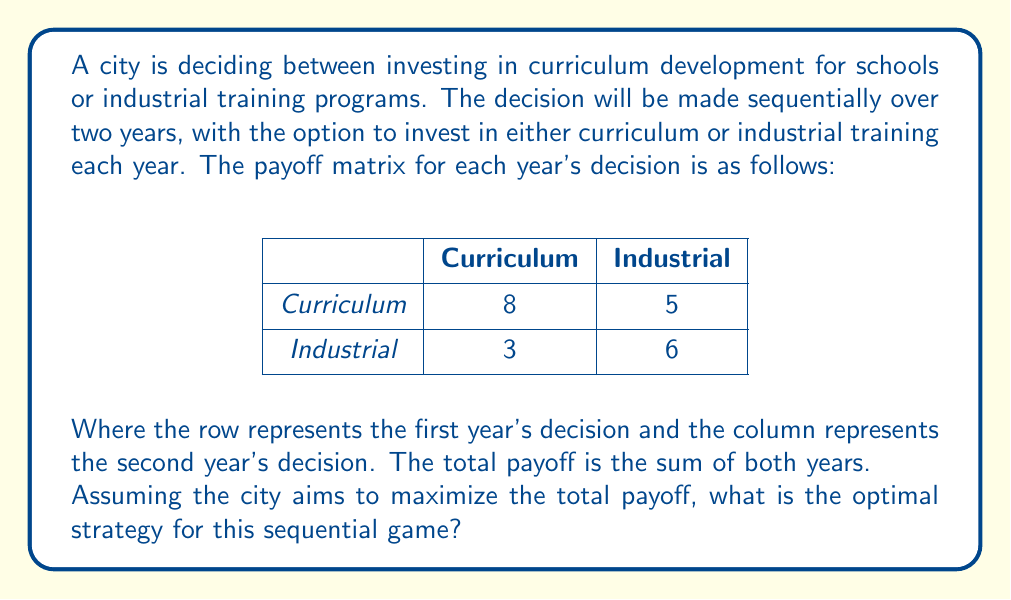Help me with this question. To solve this sequential game, we need to use backward induction. We'll start by analyzing the second year's decision based on the first year's choice.

1. If Curriculum is chosen in the first year:
   - Second year Curriculum: 8
   - Second year Industrial: 5
   The optimal choice for the second year would be Curriculum (8 > 5).

2. If Industrial is chosen in the first year:
   - Second year Curriculum: 3
   - Second year Industrial: 6
   The optimal choice for the second year would be Industrial (6 > 3).

Now, let's calculate the total payoffs for each first-year decision:

3. If Curriculum is chosen in the first year:
   Total payoff = 8 (first year) + 8 (second year) = 16

4. If Industrial is chosen in the first year:
   Total payoff = 6 (first year) + 6 (second year) = 12

5. Compare the total payoffs:
   Curriculum first: 16
   Industrial first: 12

Therefore, the optimal strategy is to choose Curriculum in both years, as it yields the highest total payoff of 16.

This result aligns with the persona of a retired teacher emphasizing the importance of quality education over rapid industrialization. The optimal strategy shows that investing in curriculum development consistently provides better long-term benefits compared to industrial training programs.
Answer: The optimal strategy is to invest in curriculum development in both years, resulting in a total payoff of 16. 